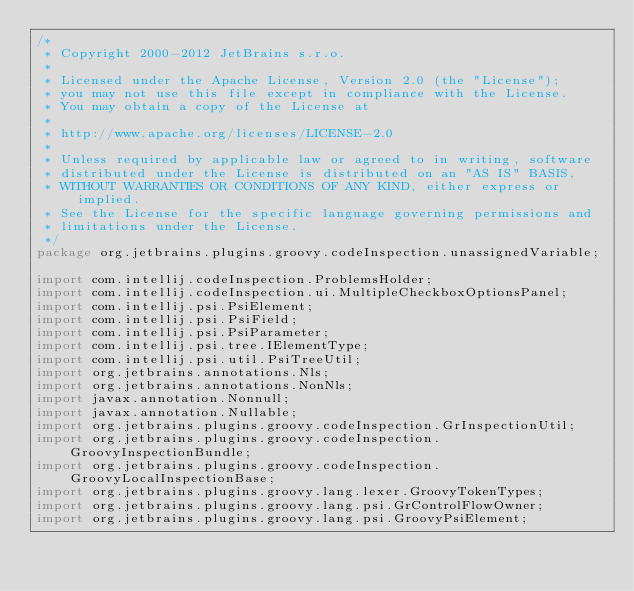<code> <loc_0><loc_0><loc_500><loc_500><_Java_>/*
 * Copyright 2000-2012 JetBrains s.r.o.
 *
 * Licensed under the Apache License, Version 2.0 (the "License");
 * you may not use this file except in compliance with the License.
 * You may obtain a copy of the License at
 *
 * http://www.apache.org/licenses/LICENSE-2.0
 *
 * Unless required by applicable law or agreed to in writing, software
 * distributed under the License is distributed on an "AS IS" BASIS,
 * WITHOUT WARRANTIES OR CONDITIONS OF ANY KIND, either express or implied.
 * See the License for the specific language governing permissions and
 * limitations under the License.
 */
package org.jetbrains.plugins.groovy.codeInspection.unassignedVariable;

import com.intellij.codeInspection.ProblemsHolder;
import com.intellij.codeInspection.ui.MultipleCheckboxOptionsPanel;
import com.intellij.psi.PsiElement;
import com.intellij.psi.PsiField;
import com.intellij.psi.PsiParameter;
import com.intellij.psi.tree.IElementType;
import com.intellij.psi.util.PsiTreeUtil;
import org.jetbrains.annotations.Nls;
import org.jetbrains.annotations.NonNls;
import javax.annotation.Nonnull;
import javax.annotation.Nullable;
import org.jetbrains.plugins.groovy.codeInspection.GrInspectionUtil;
import org.jetbrains.plugins.groovy.codeInspection.GroovyInspectionBundle;
import org.jetbrains.plugins.groovy.codeInspection.GroovyLocalInspectionBase;
import org.jetbrains.plugins.groovy.lang.lexer.GroovyTokenTypes;
import org.jetbrains.plugins.groovy.lang.psi.GrControlFlowOwner;
import org.jetbrains.plugins.groovy.lang.psi.GroovyPsiElement;</code> 